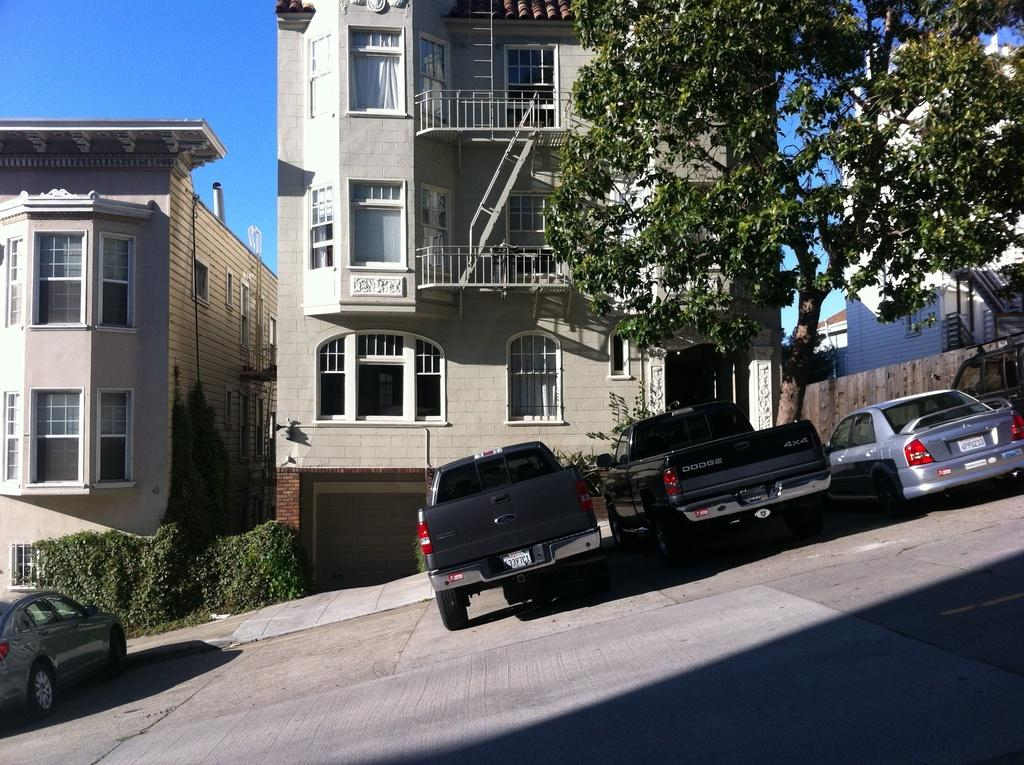What type of terrain is depicted in the image? There is a slope in the image. What can be seen on the slope? There are vehicles on the slope. What is visible behind the vehicles? There are buildings behind the vehicles. What is in front of the buildings? There are plants in front of the buildings. What type of vegetation is present in the image? There is a tree in the image. What color is the mist surrounding the vehicles in the image? There is no mist present in the image; it is a clear scene with vehicles on a slope. 